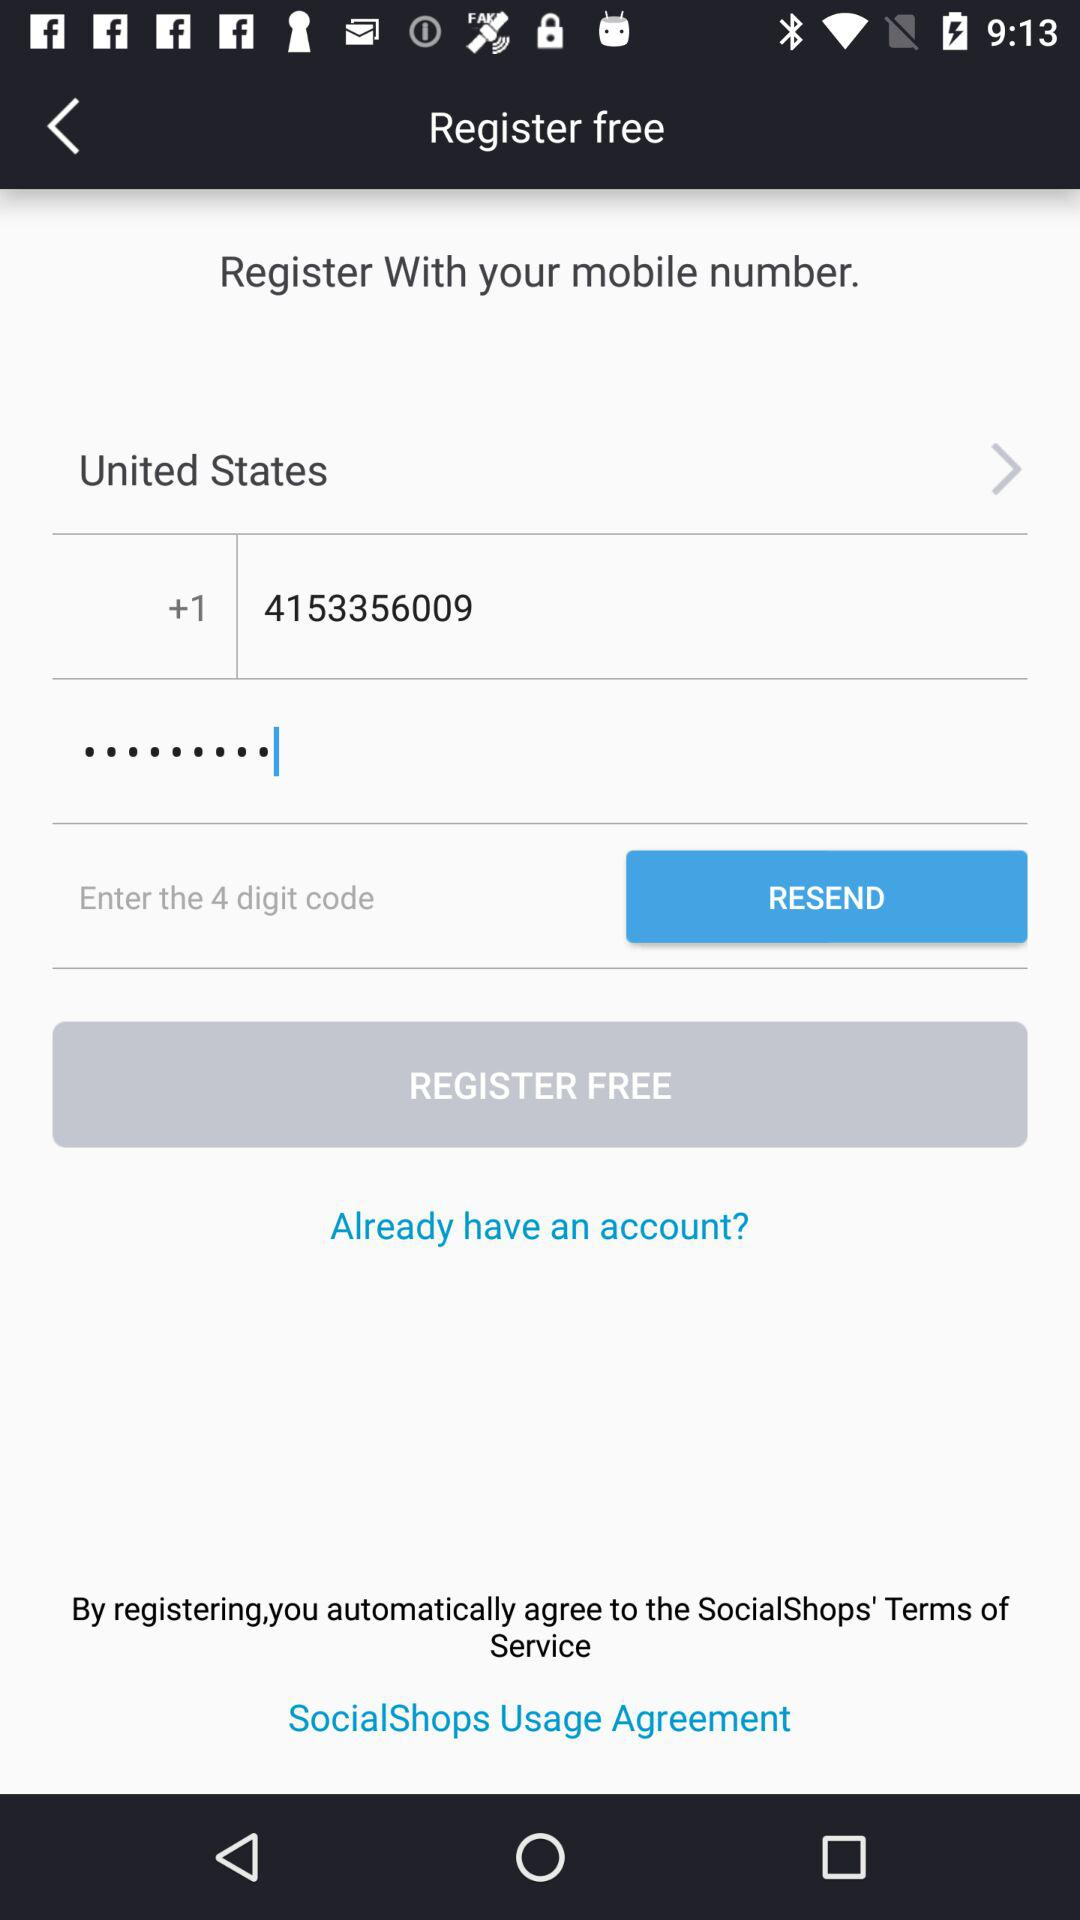How many digits are in the code?
Answer the question using a single word or phrase. 4 